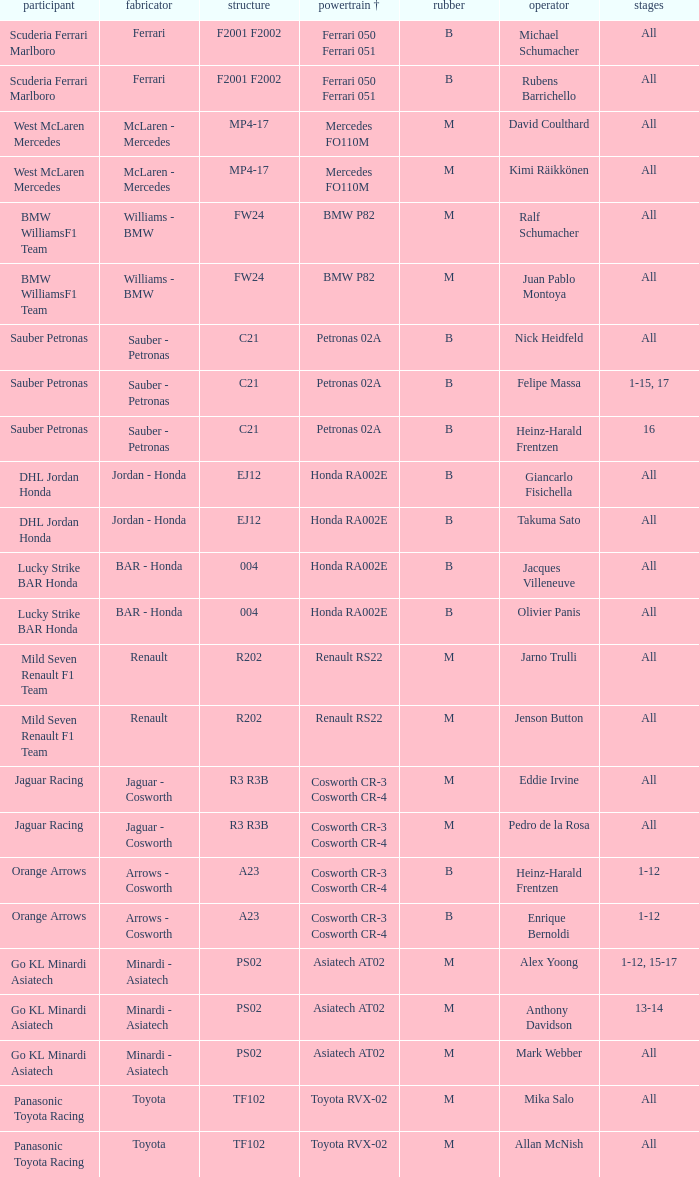What is the tyre when the engine is asiatech at02 and the driver is alex yoong? M. 